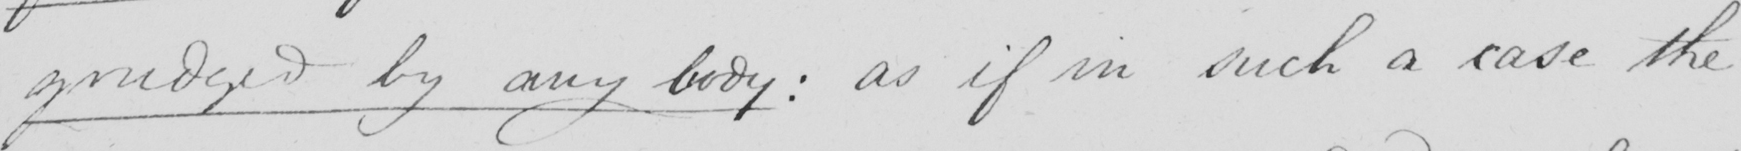What does this handwritten line say? grudged by any body :  as if in such a case the 